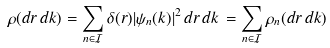Convert formula to latex. <formula><loc_0><loc_0><loc_500><loc_500>\rho ( d r \, d k ) = \sum _ { n \in \mathcal { I } } \delta ( r ) | \psi _ { n } ( k ) | ^ { 2 } \, d r \, d k \, = \sum _ { n \in \mathcal { I } } \rho _ { n } ( d r \, d k )</formula> 